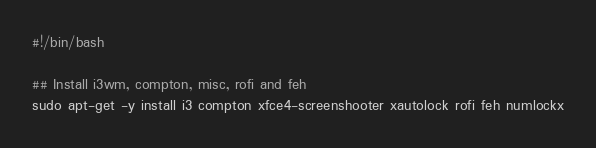<code> <loc_0><loc_0><loc_500><loc_500><_Bash_>#!/bin/bash

## Install i3wm, compton, misc, rofi and feh
sudo apt-get -y install i3 compton xfce4-screenshooter xautolock rofi feh numlockx
</code> 